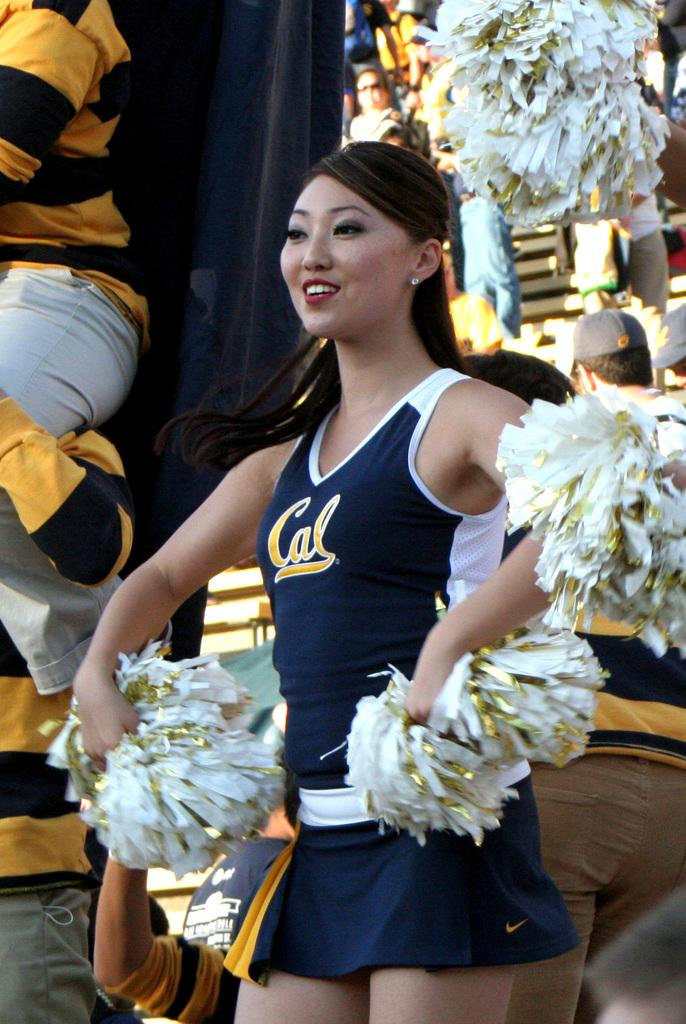<image>
Write a terse but informative summary of the picture. A cheerleader for Cal is cheering with her pom poms. 